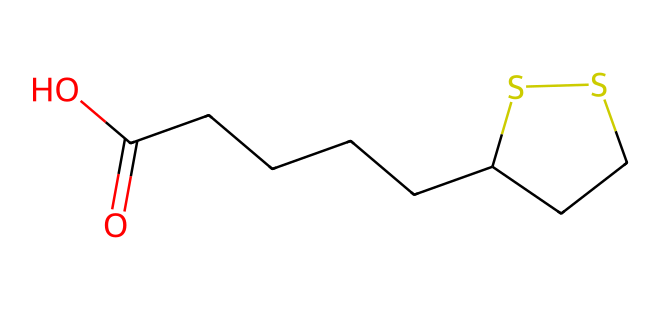how many carbon atoms are in lipoic acid? By analyzing the SMILES representation, we can identify the "C" symbols, which represent carbon atoms. In the provided SMILES, there are a total of 8 carbon atoms.
Answer: 8 what functional groups are present in lipoic acid? The SMILES structure contains a carboxylic acid functional group (-COOH) indicated by "O=C(O)" and a thioether structure with the "SS" representing sulfur. Therefore, the functional groups present are a carboxylic acid and a thioether.
Answer: carboxylic acid, thioether what is the molecular formula of lipoic acid? From the SMILES representation, we can tally the atoms: 8 carbon (C), 14 hydrogen (H), 2 oxygen (O), and 2 sulfur (S). Therefore, the molecular formula is C8H14O2S2.
Answer: C8H14O2S2 what indicates that lipoic acid is an organosulfur compound? The presence of sulfur atoms ("S") in the SMILES representation indicates that this molecule is an organosulfur compound. Organosulfur compounds are characterized by containing sulfur in their structure, which is evident here.
Answer: sulfur atoms how many rings are present in lipoic acid? The structure contains a cyclic portion indicated by "C1" and "CCSS1," which means there is one ring in the compound. Since there is a "1" that starts and ends the cyclic portion, it indicates the presence of one ring structure.
Answer: 1 what role does lipoic acid play as an antioxidant? Lipoic acid acts as a cofactor for enzyme reactions that involve the metabolism of carbohydrates. Its structure allows it to scavenge free radicals, thus functioning as an antioxidant.
Answer: antioxidant 